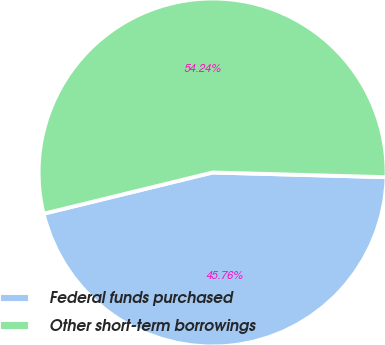Convert chart. <chart><loc_0><loc_0><loc_500><loc_500><pie_chart><fcel>Federal funds purchased<fcel>Other short-term borrowings<nl><fcel>45.76%<fcel>54.24%<nl></chart> 